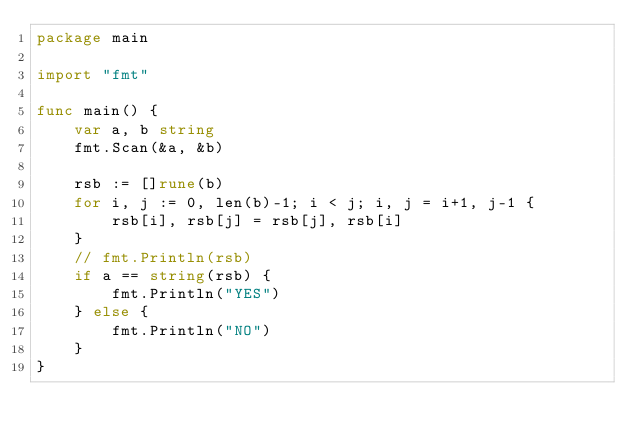Convert code to text. <code><loc_0><loc_0><loc_500><loc_500><_Go_>package main

import "fmt"

func main() {
	var a, b string
	fmt.Scan(&a, &b)

	rsb := []rune(b)
    for i, j := 0, len(b)-1; i < j; i, j = i+1, j-1 {
        rsb[i], rsb[j] = rsb[j], rsb[i]
	}
	// fmt.Println(rsb)
	if a == string(rsb) {
		fmt.Println("YES")
	} else {
		fmt.Println("NO")
	}
}</code> 